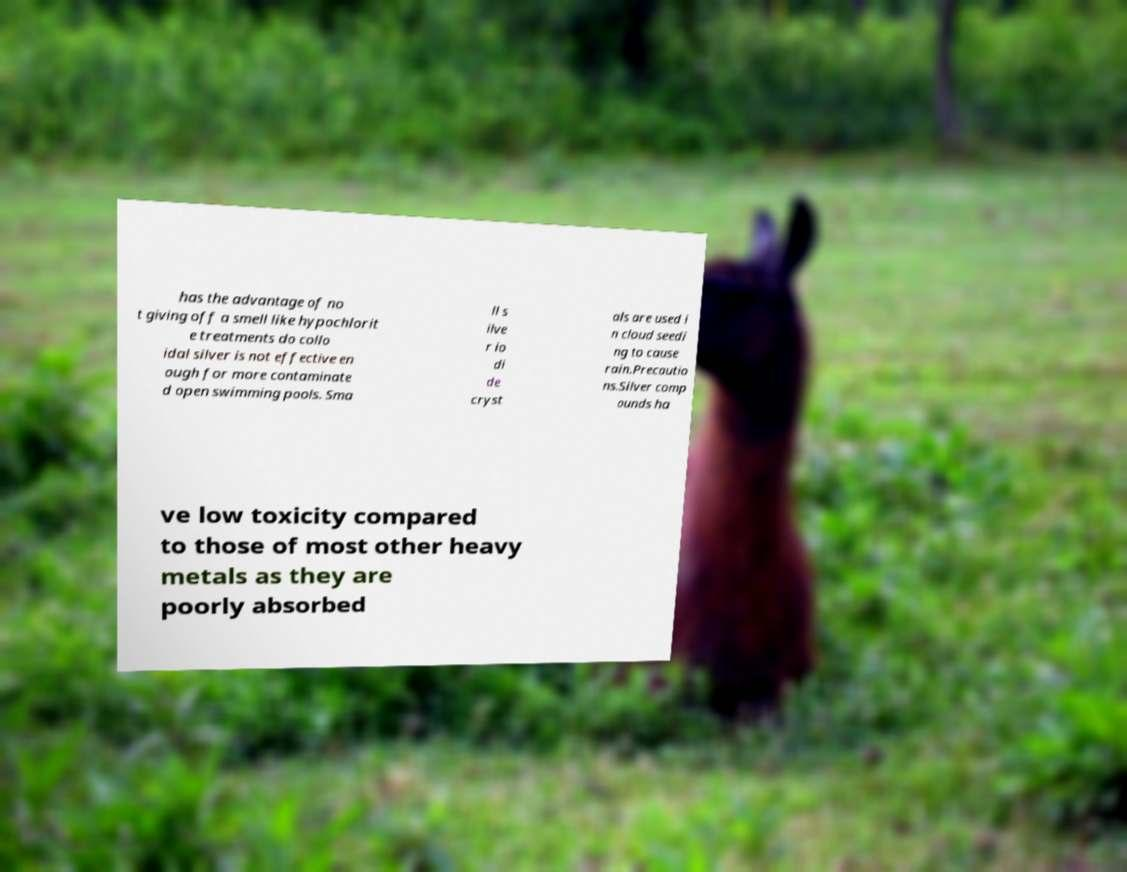What messages or text are displayed in this image? I need them in a readable, typed format. has the advantage of no t giving off a smell like hypochlorit e treatments do collo idal silver is not effective en ough for more contaminate d open swimming pools. Sma ll s ilve r io di de cryst als are used i n cloud seedi ng to cause rain.Precautio ns.Silver comp ounds ha ve low toxicity compared to those of most other heavy metals as they are poorly absorbed 